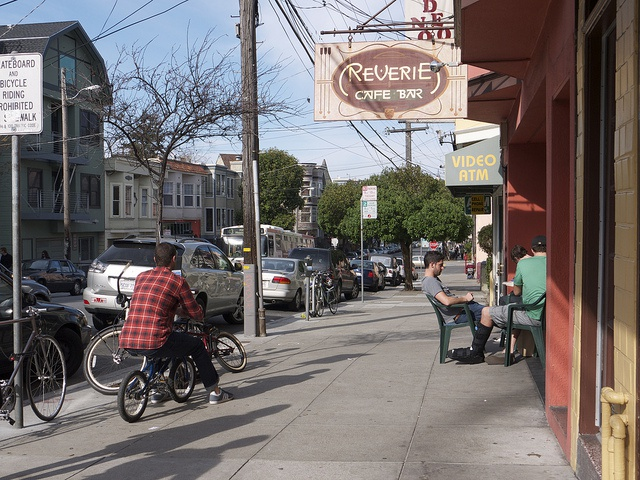Describe the objects in this image and their specific colors. I can see car in lightblue, black, gray, white, and darkgray tones, car in lightblue, black, gray, and darkgray tones, people in lightblue, black, brown, and maroon tones, bicycle in lightblue, black, gray, and darkgray tones, and people in lightblue, black, darkgray, gray, and teal tones in this image. 